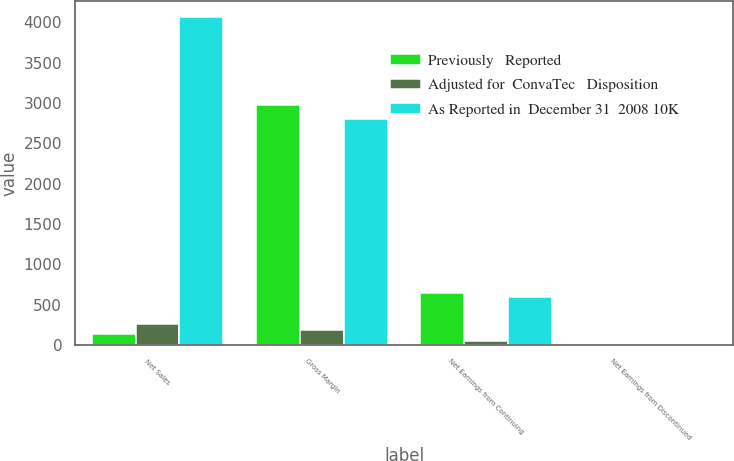Convert chart to OTSL. <chart><loc_0><loc_0><loc_500><loc_500><stacked_bar_chart><ecel><fcel>Net Sales<fcel>Gross Margin<fcel>Net Earnings from Continuing<fcel>Net Earnings from Discontinued<nl><fcel>Previously   Reported<fcel>139<fcel>2977<fcel>643<fcel>0.02<nl><fcel>Adjusted for  ConvaTec   Disposition<fcel>254<fcel>180<fcel>51<fcel>0.03<nl><fcel>As Reported in  December 31  2008 10K<fcel>4063<fcel>2797<fcel>592<fcel>0.05<nl></chart> 